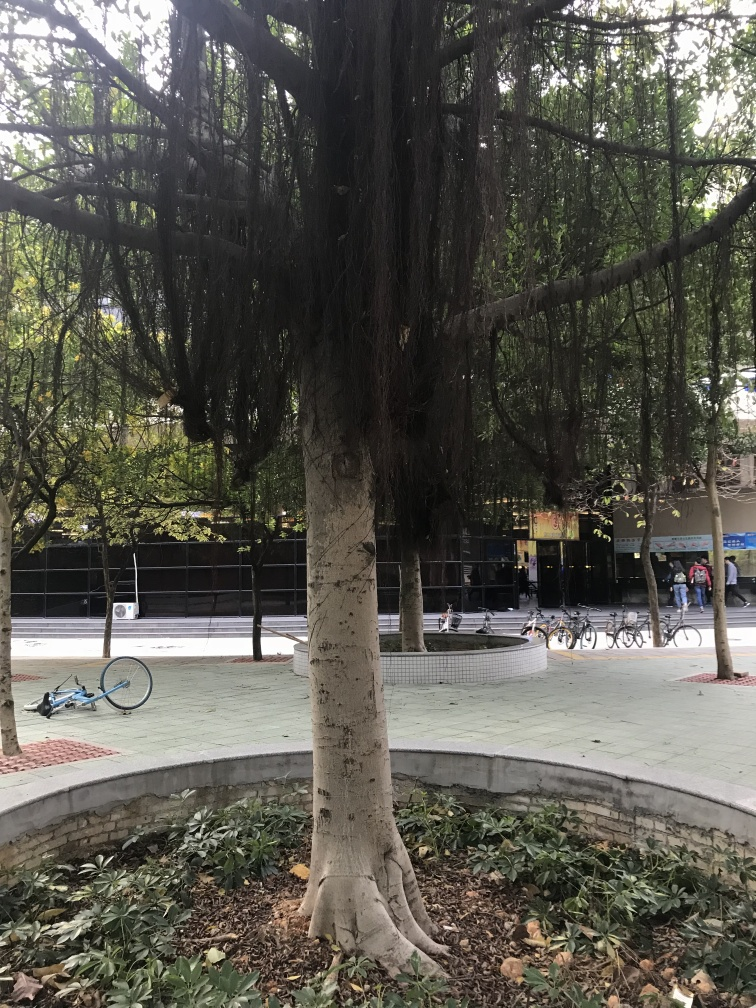What is the quality of the image?
A. Good
B. Excellent
C. Average The quality of the image can be considered as good (A), showing clear details and proper lighting. However, it could be rated as average by some due to the presence of shadows and perhaps a lack of vibrant colors or high dynamics that some might associate with excellence. The subjects within the frame are well captured and visible, but there is room for improvement in terms of composition and balance. 